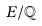Convert formula to latex. <formula><loc_0><loc_0><loc_500><loc_500>E / \mathbb { Q }</formula> 